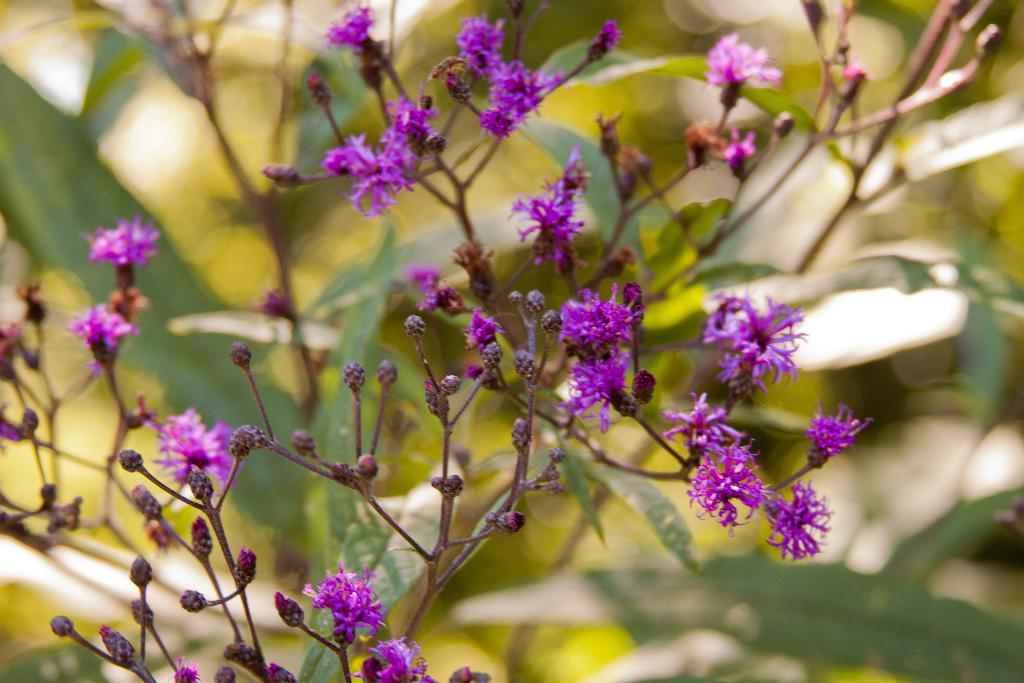What is the main subject of the image? The main subject of the image is flowers and buds in the center. What type of vegetation can be seen in the background of the image? There are green leaves in the background of the image. Are there any other objects visible in the background? Yes, there are other objects visible in the background of the image. What type of ornament is hanging from the collar of the person in the image? There is no person or collar present in the image; it features flowers and buds with green leaves in the background. 